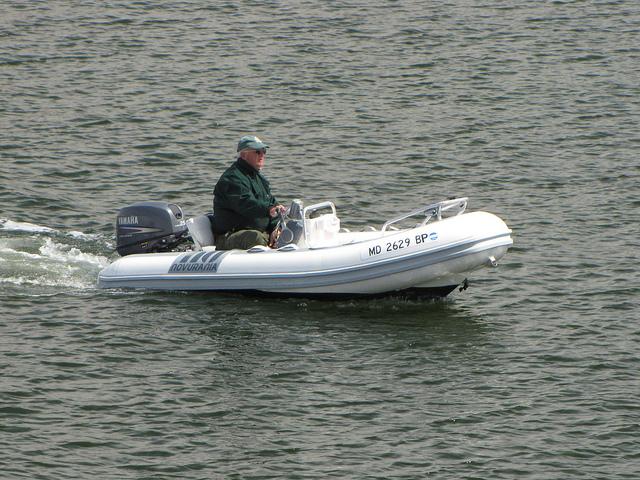Is anyone water skiing?
Answer briefly. No. What is in the water?
Concise answer only. Boat. Is the man fishing from the boat?
Give a very brief answer. No. Could this be an inflatable boat?
Concise answer only. Yes. How many people are in the boat?
Keep it brief. 1. 